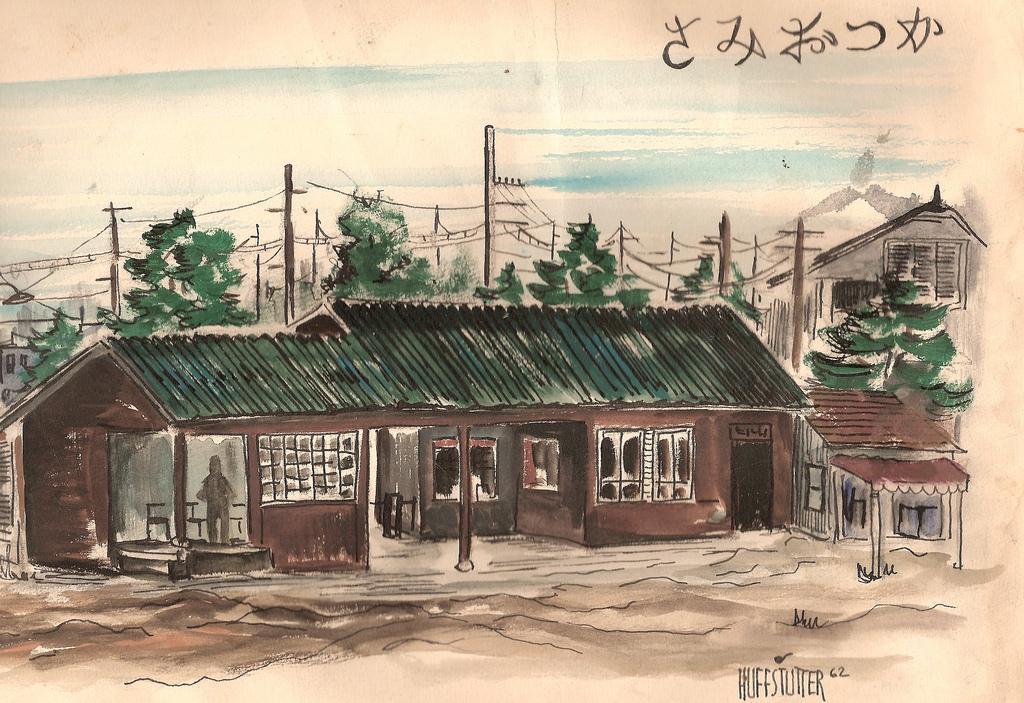How would you summarize this image in a sentence or two? In this image I can see houses,trees,windows,current poles and wires. The sky is in white and blue color. 